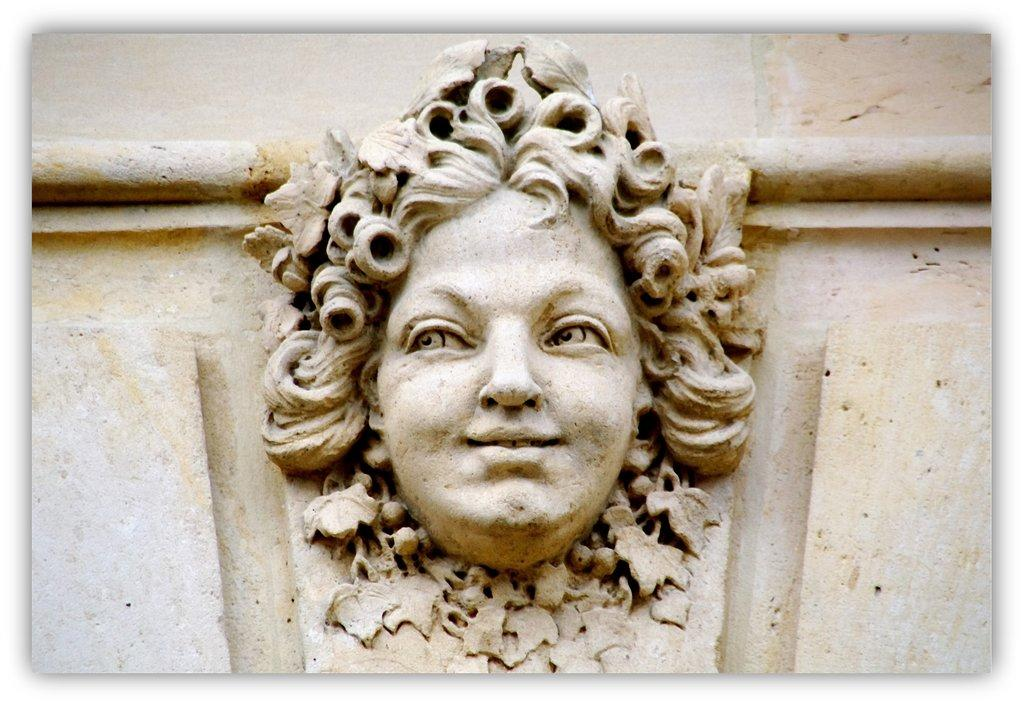What is the main subject of the image? There is a sculpture in the middle of the image. Can you describe the sculpture in more detail? Unfortunately, the provided facts do not offer any additional details about the sculpture. Is there anything else visible in the image besides the sculpture? The provided facts do not mention any other objects or subjects in the image. How does the sculpture transport water from one basin to another in the image? There is no basin or water transport system present in the image; it only features a sculpture. What type of brake system is used on the sculpture in the image? There is no brake system present on the sculpture in the image, as it is a static object. 